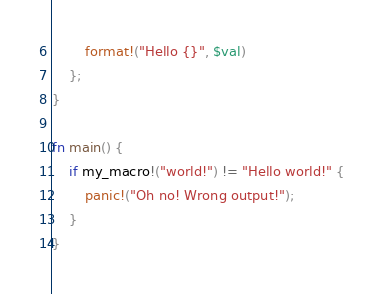<code> <loc_0><loc_0><loc_500><loc_500><_Rust_>        format!("Hello {}", $val)
    };
}

fn main() {
    if my_macro!("world!") != "Hello world!" {
        panic!("Oh no! Wrong output!");
    }
}
</code> 